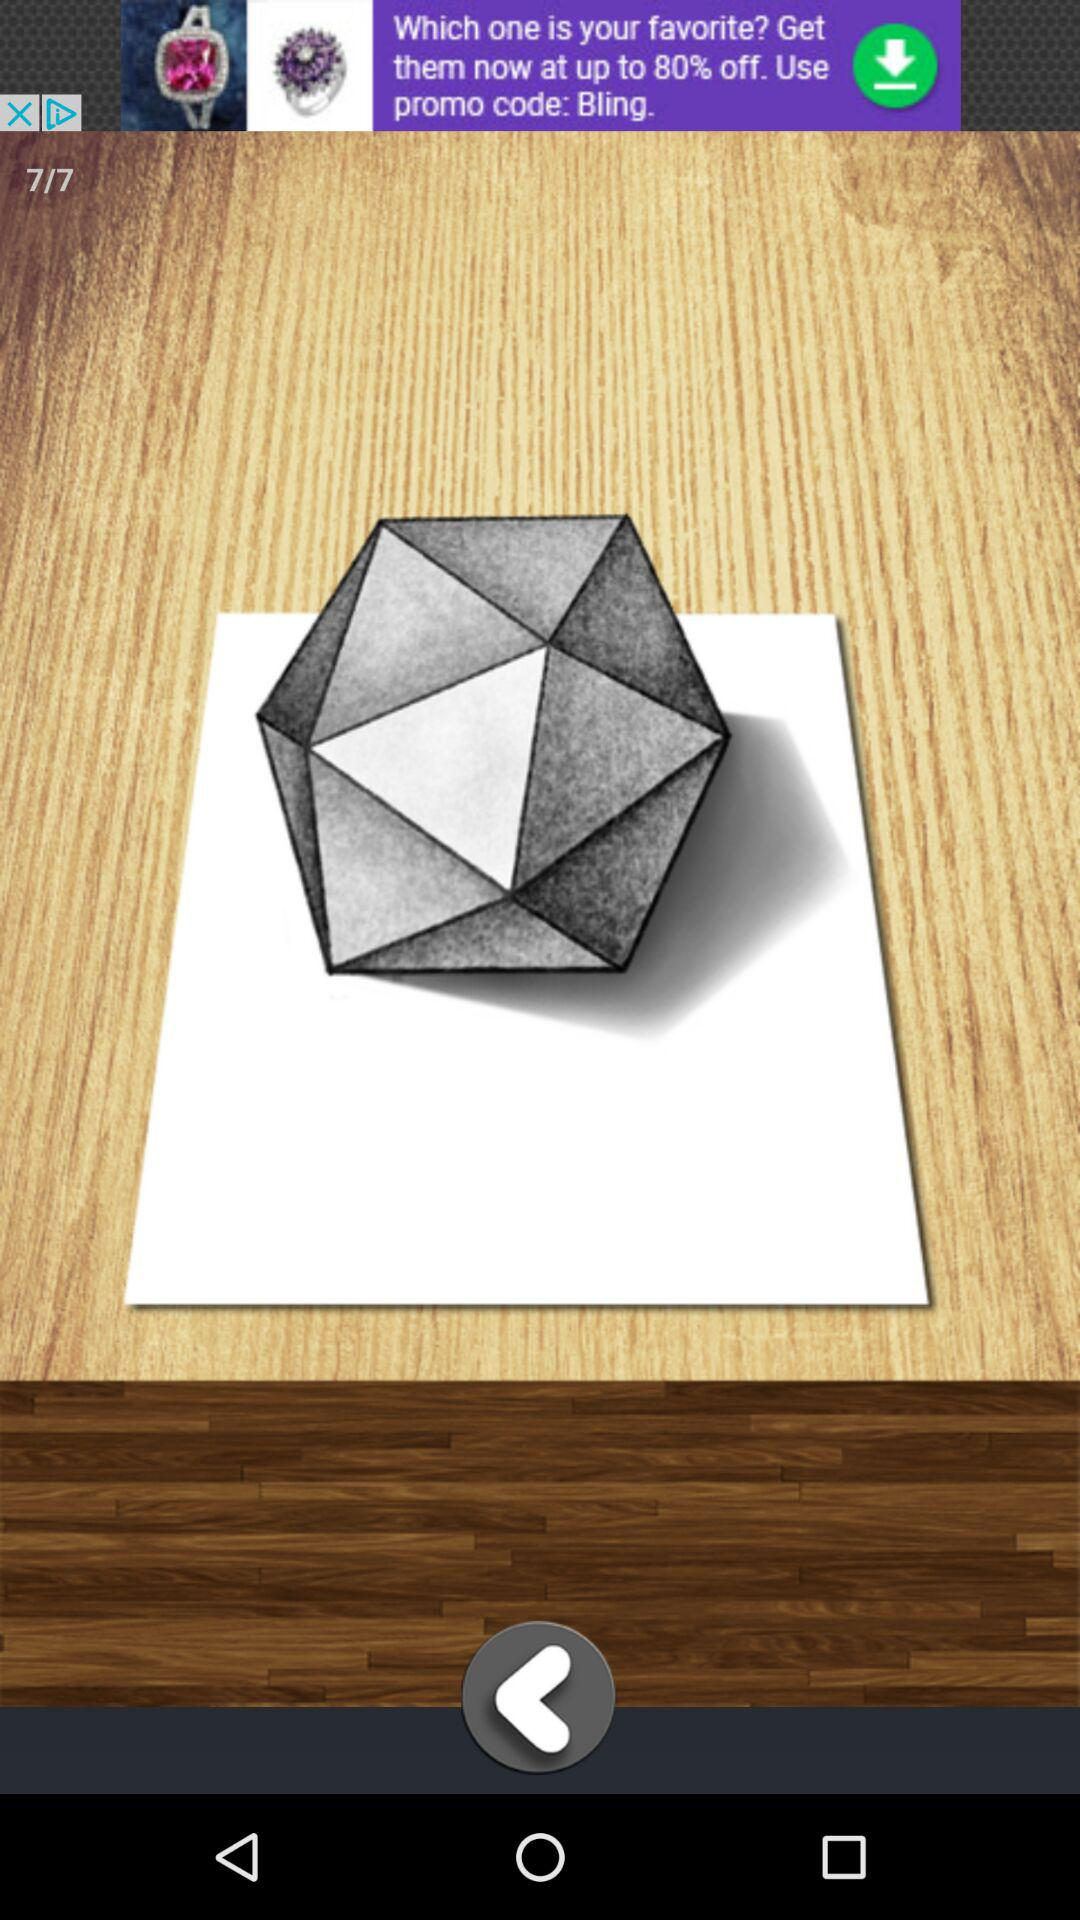When will the image be completely drawn?
When the provided information is insufficient, respond with <no answer>. <no answer> 